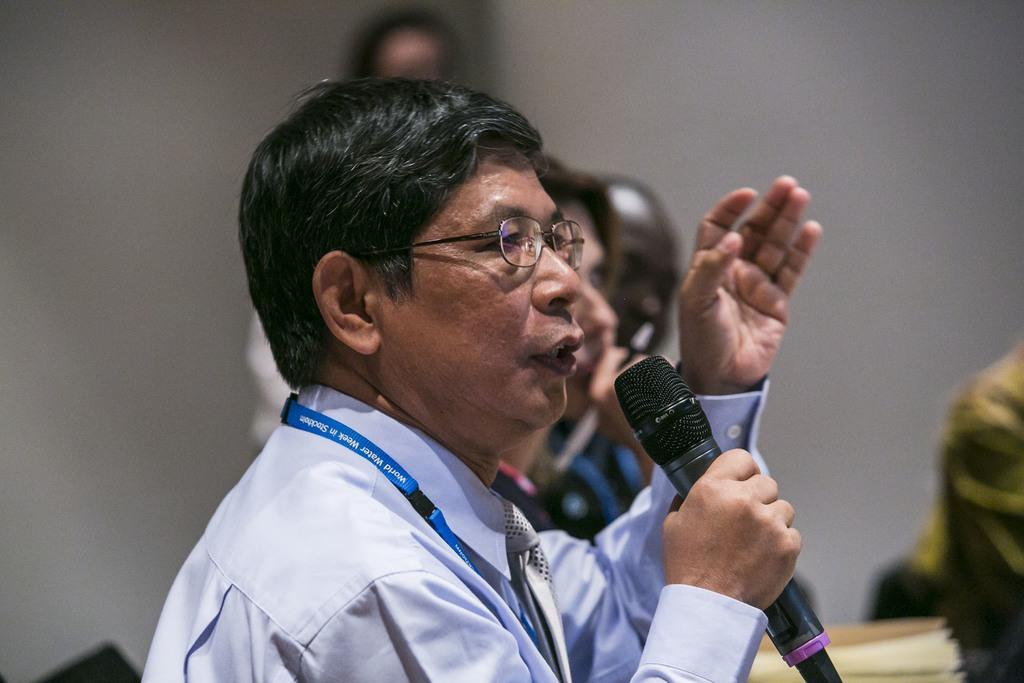In one or two sentences, can you explain what this image depicts? This image consists of a man talking in a mic. He is wearing a blue shirt. There are few more persons in this image. In the background, there is a wall. 